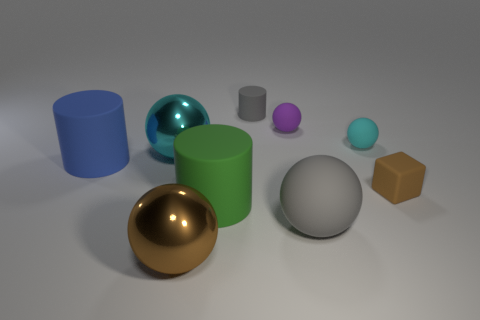Is there a big metal ball? yes 